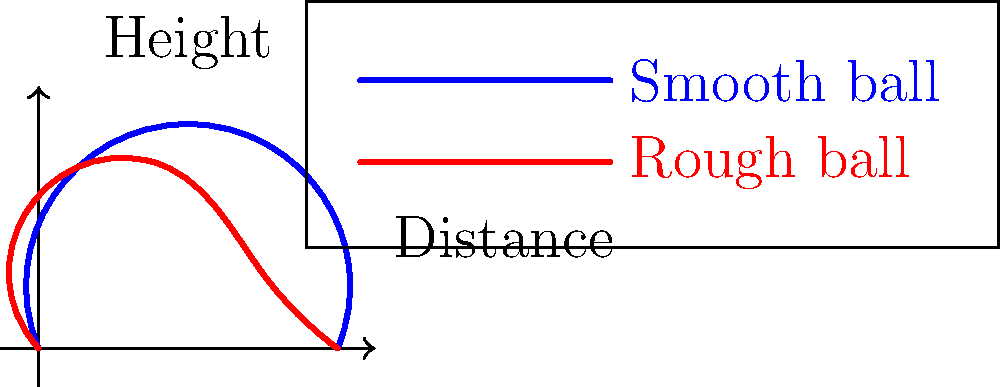Based on the flight paths shown in the graph, which type of soccer ball design is likely to have a more predictable trajectory and why? To answer this question, let's analyze the flight paths shown in the graph:

1. Blue path (smooth ball):
   - Shows a more symmetrical and parabolic trajectory
   - Reaches a higher maximum height
   - Has a smoother descent

2. Red path (rough ball):
   - Shows an asymmetrical and irregular trajectory
   - Reaches a lower maximum height
   - Has more fluctuations in its path

The smoother, more symmetrical path of the blue line suggests a more predictable trajectory. This is because:

1. Aerodynamics: A smooth ball creates less air turbulence, resulting in less random movement.
2. Magnus effect: The spin on a smooth ball is more consistent, leading to a more predictable curve.
3. Stability: The smooth ball's trajectory is less affected by small air currents or imperfections in the kick.

In contrast, the rough ball's irregular path indicates that its flight is more susceptible to external factors and harder to predict.

Therefore, the smooth ball design is likely to have a more predictable trajectory.
Answer: Smooth ball design 